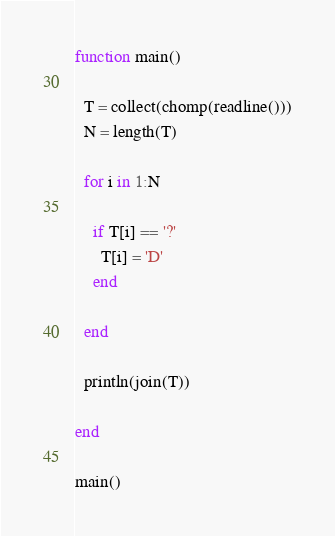Convert code to text. <code><loc_0><loc_0><loc_500><loc_500><_Julia_>function main()
  
  T = collect(chomp(readline()))
  N = length(T)
  
  for i in 1:N
    
    if T[i] == '?'
      T[i] = 'D'
    end
    
  end
  
  println(join(T))
  
end

main()</code> 